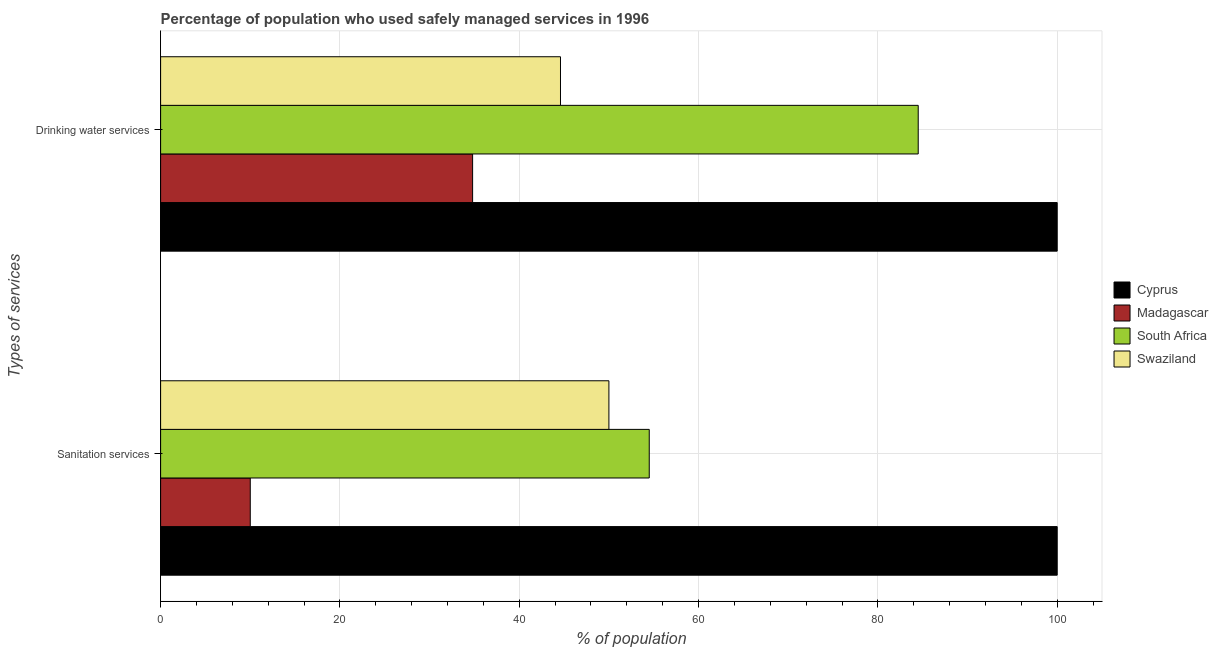How many groups of bars are there?
Provide a succinct answer. 2. Are the number of bars per tick equal to the number of legend labels?
Your answer should be compact. Yes. Are the number of bars on each tick of the Y-axis equal?
Your answer should be very brief. Yes. How many bars are there on the 2nd tick from the bottom?
Make the answer very short. 4. What is the label of the 2nd group of bars from the top?
Your response must be concise. Sanitation services. What is the percentage of population who used sanitation services in Swaziland?
Give a very brief answer. 50. Across all countries, what is the minimum percentage of population who used sanitation services?
Offer a terse response. 10. In which country was the percentage of population who used drinking water services maximum?
Offer a terse response. Cyprus. In which country was the percentage of population who used drinking water services minimum?
Make the answer very short. Madagascar. What is the total percentage of population who used drinking water services in the graph?
Give a very brief answer. 263.9. What is the difference between the percentage of population who used drinking water services in Cyprus and that in South Africa?
Your answer should be very brief. 15.5. What is the difference between the percentage of population who used drinking water services in Swaziland and the percentage of population who used sanitation services in Madagascar?
Make the answer very short. 34.6. What is the average percentage of population who used drinking water services per country?
Your response must be concise. 65.98. What is the ratio of the percentage of population who used drinking water services in South Africa to that in Swaziland?
Keep it short and to the point. 1.89. What does the 3rd bar from the top in Sanitation services represents?
Keep it short and to the point. Madagascar. What does the 4th bar from the bottom in Drinking water services represents?
Make the answer very short. Swaziland. How many bars are there?
Make the answer very short. 8. How many countries are there in the graph?
Your answer should be compact. 4. What is the difference between two consecutive major ticks on the X-axis?
Offer a terse response. 20. Are the values on the major ticks of X-axis written in scientific E-notation?
Your answer should be compact. No. Does the graph contain grids?
Provide a succinct answer. Yes. Where does the legend appear in the graph?
Keep it short and to the point. Center right. How are the legend labels stacked?
Your answer should be very brief. Vertical. What is the title of the graph?
Ensure brevity in your answer.  Percentage of population who used safely managed services in 1996. What is the label or title of the X-axis?
Give a very brief answer. % of population. What is the label or title of the Y-axis?
Your response must be concise. Types of services. What is the % of population in Madagascar in Sanitation services?
Ensure brevity in your answer.  10. What is the % of population of South Africa in Sanitation services?
Your answer should be very brief. 54.5. What is the % of population of Madagascar in Drinking water services?
Give a very brief answer. 34.8. What is the % of population of South Africa in Drinking water services?
Ensure brevity in your answer.  84.5. What is the % of population of Swaziland in Drinking water services?
Your answer should be very brief. 44.6. Across all Types of services, what is the maximum % of population in Madagascar?
Keep it short and to the point. 34.8. Across all Types of services, what is the maximum % of population of South Africa?
Provide a succinct answer. 84.5. Across all Types of services, what is the minimum % of population of Madagascar?
Provide a succinct answer. 10. Across all Types of services, what is the minimum % of population of South Africa?
Your answer should be compact. 54.5. Across all Types of services, what is the minimum % of population of Swaziland?
Offer a very short reply. 44.6. What is the total % of population in Cyprus in the graph?
Offer a terse response. 200. What is the total % of population of Madagascar in the graph?
Ensure brevity in your answer.  44.8. What is the total % of population in South Africa in the graph?
Your answer should be very brief. 139. What is the total % of population in Swaziland in the graph?
Your response must be concise. 94.6. What is the difference between the % of population in Cyprus in Sanitation services and that in Drinking water services?
Keep it short and to the point. 0. What is the difference between the % of population in Madagascar in Sanitation services and that in Drinking water services?
Your response must be concise. -24.8. What is the difference between the % of population in Cyprus in Sanitation services and the % of population in Madagascar in Drinking water services?
Give a very brief answer. 65.2. What is the difference between the % of population of Cyprus in Sanitation services and the % of population of Swaziland in Drinking water services?
Provide a short and direct response. 55.4. What is the difference between the % of population in Madagascar in Sanitation services and the % of population in South Africa in Drinking water services?
Offer a terse response. -74.5. What is the difference between the % of population in Madagascar in Sanitation services and the % of population in Swaziland in Drinking water services?
Keep it short and to the point. -34.6. What is the difference between the % of population in South Africa in Sanitation services and the % of population in Swaziland in Drinking water services?
Keep it short and to the point. 9.9. What is the average % of population of Madagascar per Types of services?
Keep it short and to the point. 22.4. What is the average % of population in South Africa per Types of services?
Offer a very short reply. 69.5. What is the average % of population in Swaziland per Types of services?
Offer a terse response. 47.3. What is the difference between the % of population of Cyprus and % of population of Madagascar in Sanitation services?
Your answer should be compact. 90. What is the difference between the % of population of Cyprus and % of population of South Africa in Sanitation services?
Your response must be concise. 45.5. What is the difference between the % of population of Cyprus and % of population of Swaziland in Sanitation services?
Make the answer very short. 50. What is the difference between the % of population in Madagascar and % of population in South Africa in Sanitation services?
Your answer should be compact. -44.5. What is the difference between the % of population of Madagascar and % of population of Swaziland in Sanitation services?
Provide a short and direct response. -40. What is the difference between the % of population of Cyprus and % of population of Madagascar in Drinking water services?
Provide a succinct answer. 65.2. What is the difference between the % of population in Cyprus and % of population in South Africa in Drinking water services?
Provide a succinct answer. 15.5. What is the difference between the % of population in Cyprus and % of population in Swaziland in Drinking water services?
Offer a terse response. 55.4. What is the difference between the % of population in Madagascar and % of population in South Africa in Drinking water services?
Make the answer very short. -49.7. What is the difference between the % of population in South Africa and % of population in Swaziland in Drinking water services?
Keep it short and to the point. 39.9. What is the ratio of the % of population in Cyprus in Sanitation services to that in Drinking water services?
Offer a terse response. 1. What is the ratio of the % of population in Madagascar in Sanitation services to that in Drinking water services?
Provide a short and direct response. 0.29. What is the ratio of the % of population in South Africa in Sanitation services to that in Drinking water services?
Provide a short and direct response. 0.65. What is the ratio of the % of population of Swaziland in Sanitation services to that in Drinking water services?
Your response must be concise. 1.12. What is the difference between the highest and the second highest % of population of Madagascar?
Provide a short and direct response. 24.8. What is the difference between the highest and the second highest % of population in South Africa?
Your response must be concise. 30. What is the difference between the highest and the second highest % of population in Swaziland?
Provide a short and direct response. 5.4. What is the difference between the highest and the lowest % of population in Madagascar?
Offer a terse response. 24.8. What is the difference between the highest and the lowest % of population in South Africa?
Your answer should be very brief. 30. 